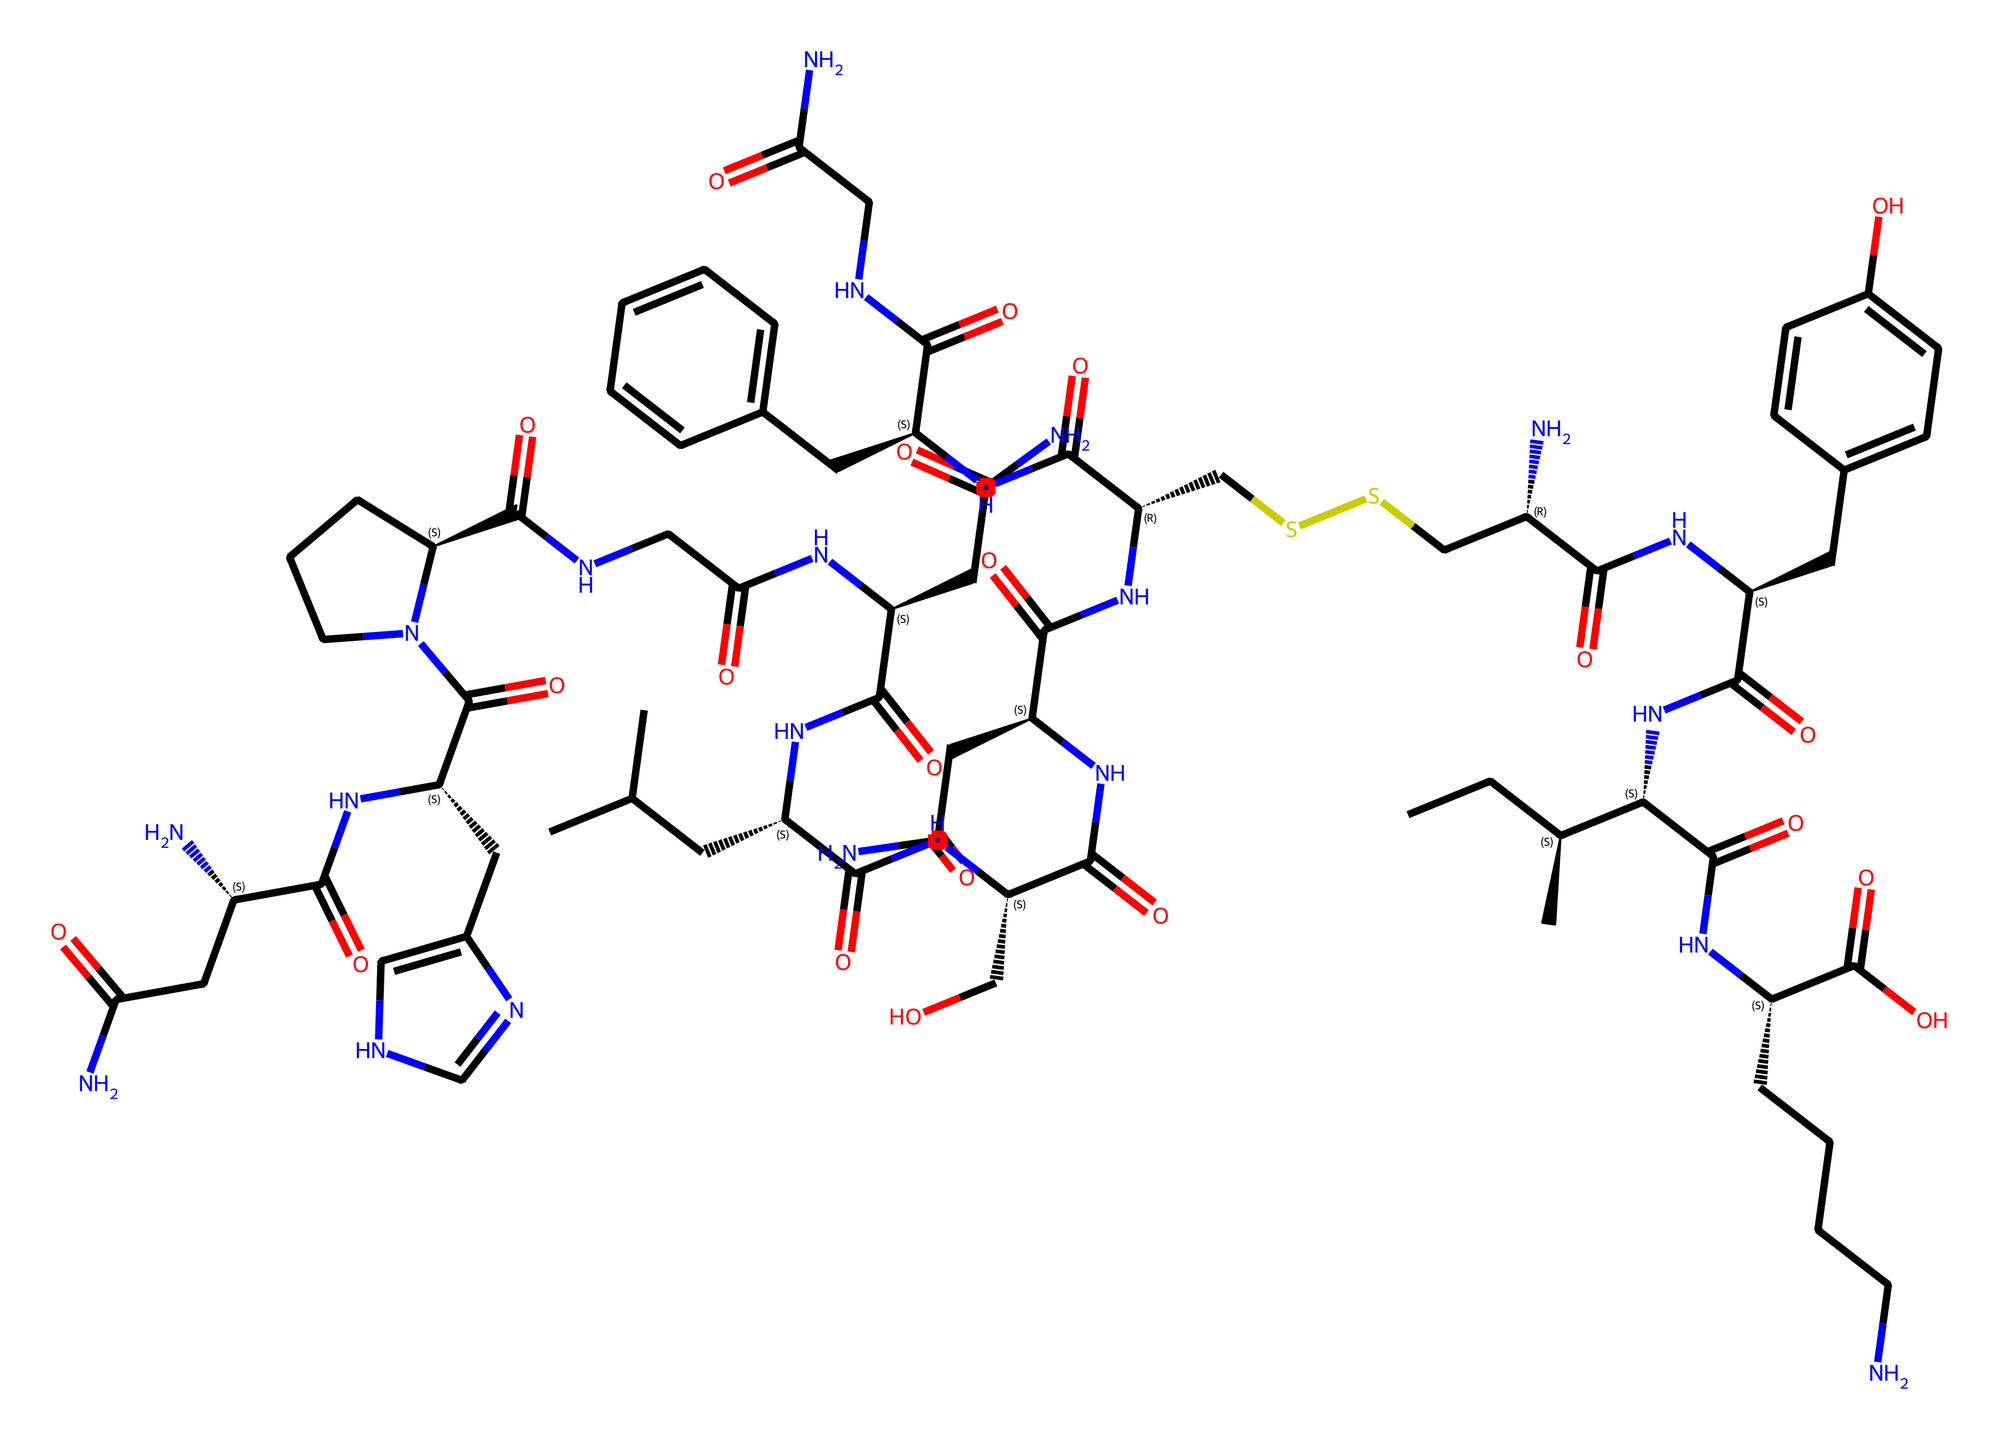What is the total number of carbon atoms in this molecule? To determine the number of carbon atoms, we can analyze the SMILES representation and identify each segment that includes 'C'. Counting the 'C' labels gives us a total of 40 carbon atoms.
Answer: 40 How many nitrogen atoms are present in the molecule? By reviewing the SMILES, we look for the 'N' notation, which represents nitrogen. Upon counting, we see there are 10 nitrogen atoms present in the entire structure.
Answer: 10 What type of functional groups are represented in this molecular structure? We can analyze the SMILES in terms of recognizable functional groups. The presence of 'C(=O)' indicates carbonyl groups, while 'C(C' indicates aliphatic chains. This compound primarily contains amide and alcohol functional groups as well.
Answer: amide and alcohol What is the significance of the 'C(=O)N' segments in this compound? The segments 'C(=O)N' represent amide linkages, which are formed between a carbonyl and an amine. These functional groups are crucial for the chemical's structural integrity and its biological activity, contributing to its role in bonding and stress reduction.
Answer: amide linkages Identify one reason why the molecule is classified as an aliphatic compound. Aliphatic compounds are characterized by straight or branched carbon chains, as seen in this molecule, which has multiple branched chains and does not contain any aromatic rings, thus fitting the definition of aliphatic compounds.
Answer: branched carbon chains 